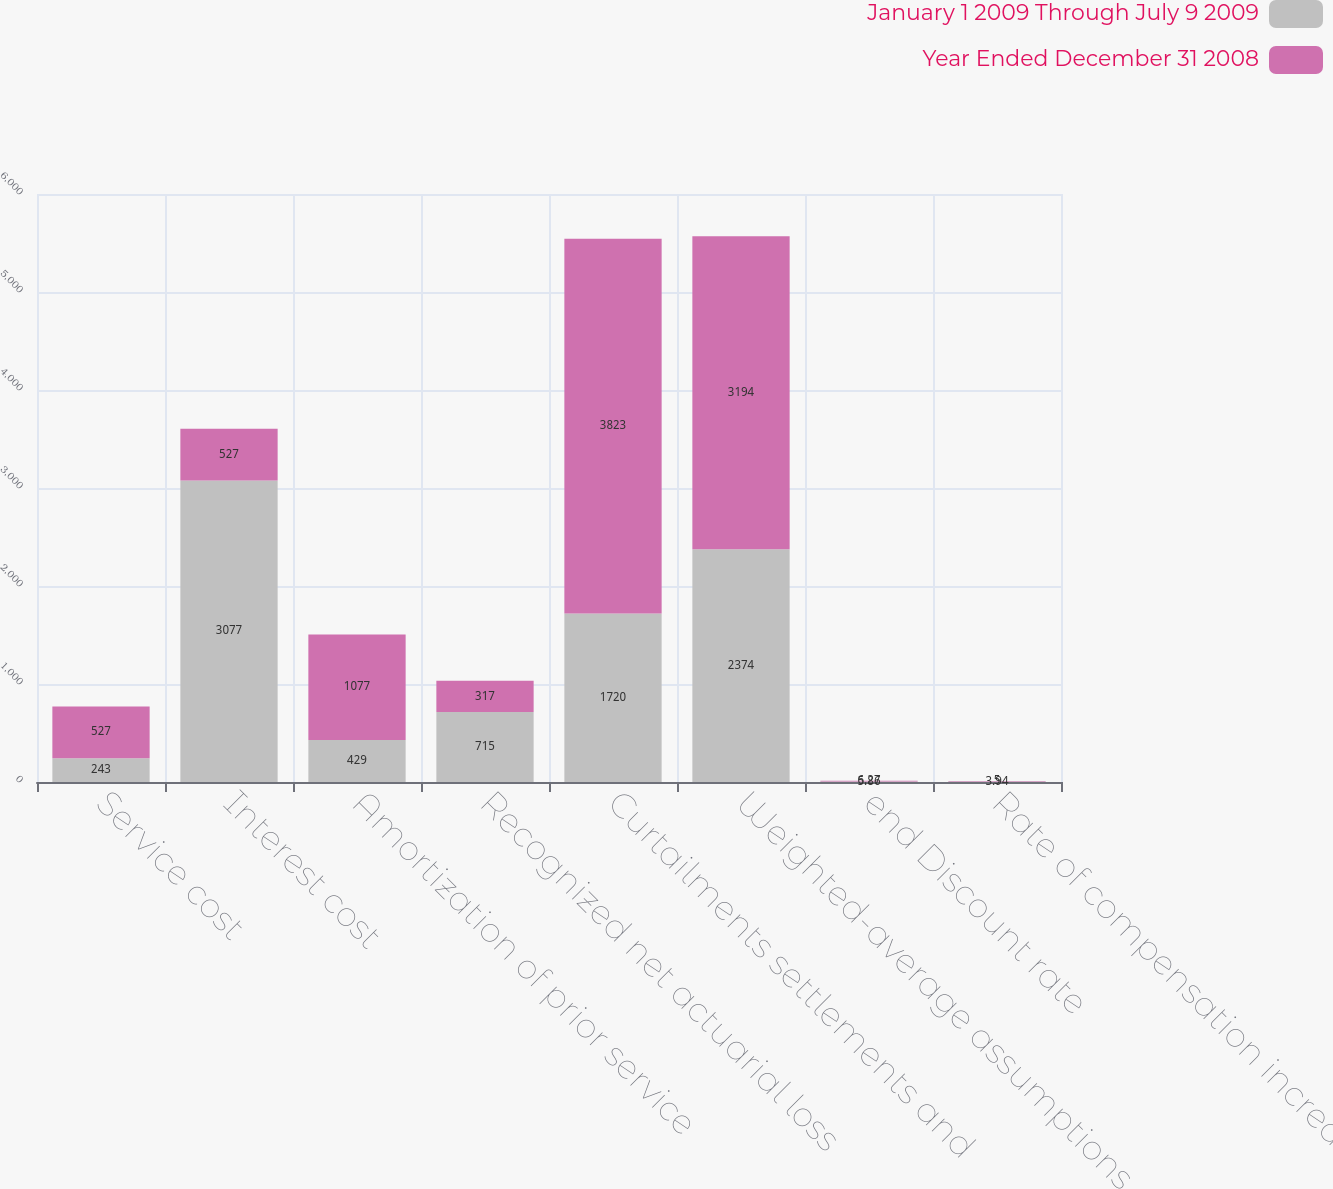Convert chart to OTSL. <chart><loc_0><loc_0><loc_500><loc_500><stacked_bar_chart><ecel><fcel>Service cost<fcel>Interest cost<fcel>Amortization of prior service<fcel>Recognized net actuarial loss<fcel>Curtailments settlements and<fcel>Weighted-average assumptions<fcel>end Discount rate<fcel>Rate of compensation increase<nl><fcel>January 1 2009 Through July 9 2009<fcel>243<fcel>3077<fcel>429<fcel>715<fcel>1720<fcel>2374<fcel>5.86<fcel>3.94<nl><fcel>Year Ended December 31 2008<fcel>527<fcel>527<fcel>1077<fcel>317<fcel>3823<fcel>3194<fcel>6.27<fcel>5<nl></chart> 